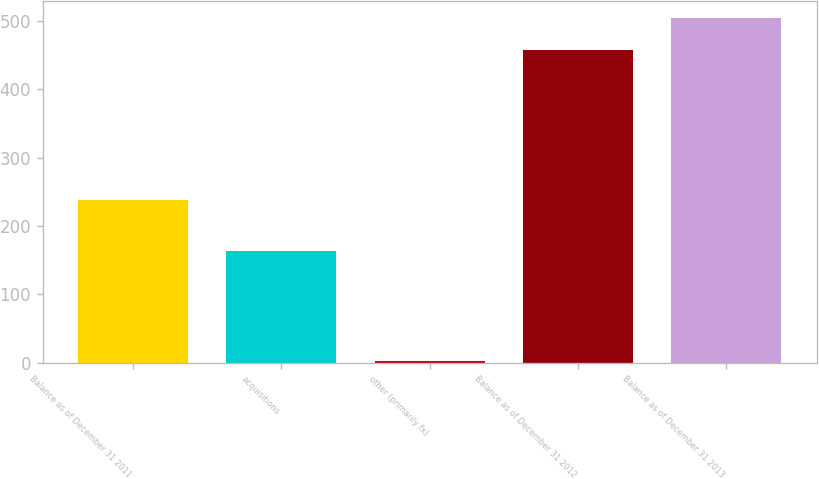<chart> <loc_0><loc_0><loc_500><loc_500><bar_chart><fcel>Balance as of December 31 2011<fcel>acquisitions<fcel>other (primarily fx)<fcel>Balance as of December 31 2012<fcel>Balance as of December 31 2013<nl><fcel>238<fcel>164<fcel>2<fcel>457<fcel>503.7<nl></chart> 